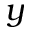Convert formula to latex. <formula><loc_0><loc_0><loc_500><loc_500>y</formula> 